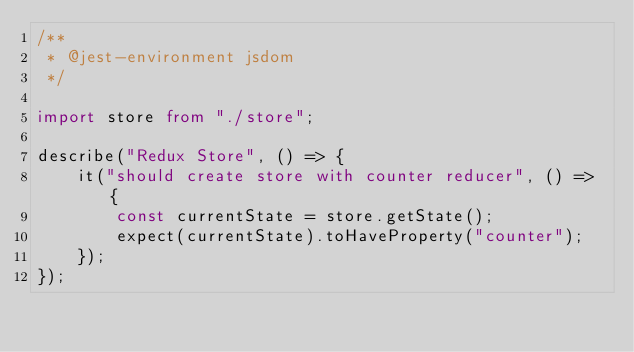Convert code to text. <code><loc_0><loc_0><loc_500><loc_500><_TypeScript_>/**
 * @jest-environment jsdom
 */

import store from "./store";

describe("Redux Store", () => {
    it("should create store with counter reducer", () => {
        const currentState = store.getState();
        expect(currentState).toHaveProperty("counter");
    });
});
</code> 